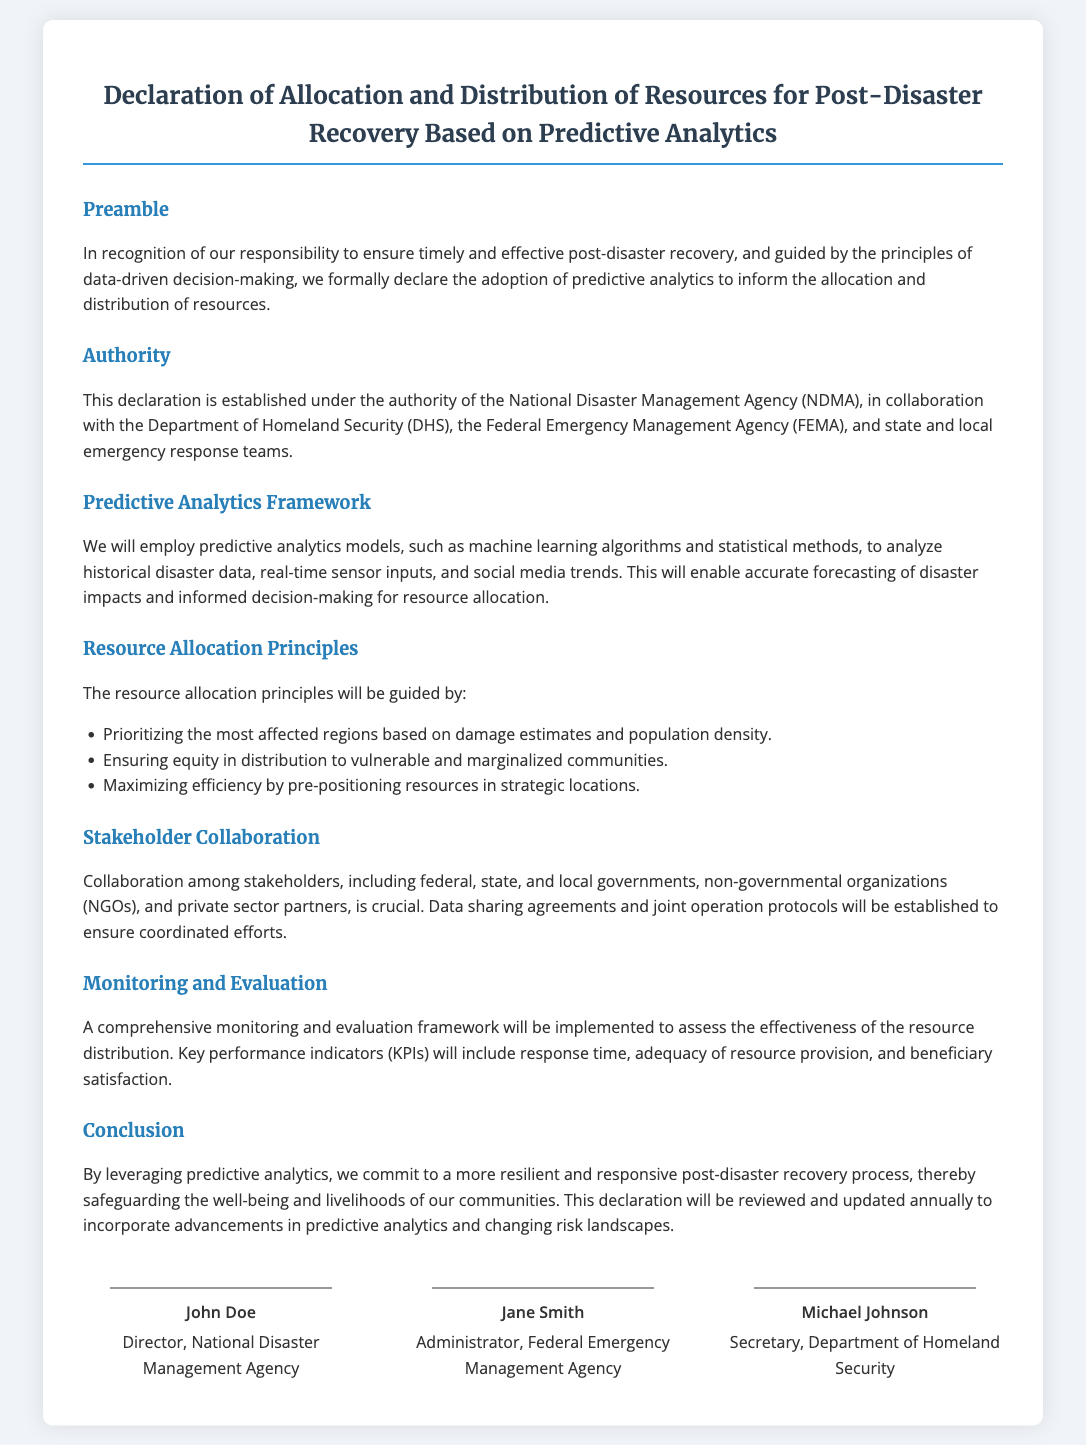what is the title of the document? The title of the document is found at the top and outlines the main subject of the declaration.
Answer: Declaration of Allocation and Distribution of Resources for Post-Disaster Recovery Based on Predictive Analytics who is the director of the National Disaster Management Agency? This information is specified under the signatures section, indicating the signatory responsible for the agency.
Answer: John Doe which agency collaborates with the National Disaster Management Agency? The document lists multiple agencies that collaborate, and this is a direct reference within the authority section.
Answer: Department of Homeland Security what is one principle for resource allocation mentioned in the document? The document explicitly states principles under the resource allocation section illustrating how resources should be distributed.
Answer: Prioritizing the most affected regions based on damage estimates and population density how often will the declaration be reviewed? This detail is outlined in the conclusion section, stating the regularity of the document's assessment and updates.
Answer: Annually which stakeholders are mentioned as crucial for collaboration? In the stakeholder collaboration section, various groups that are vital for coordinated efforts are identified.
Answer: Federal, state, and local governments what is one key performance indicator for monitoring and evaluation? The document describes indicators that will measure the effectiveness of resource distribution in the monitoring section.
Answer: Response time who is the administrator of the Federal Emergency Management Agency? This is specified in the signatures section, highlighting the individual representing the agency.
Answer: Jane Smith 